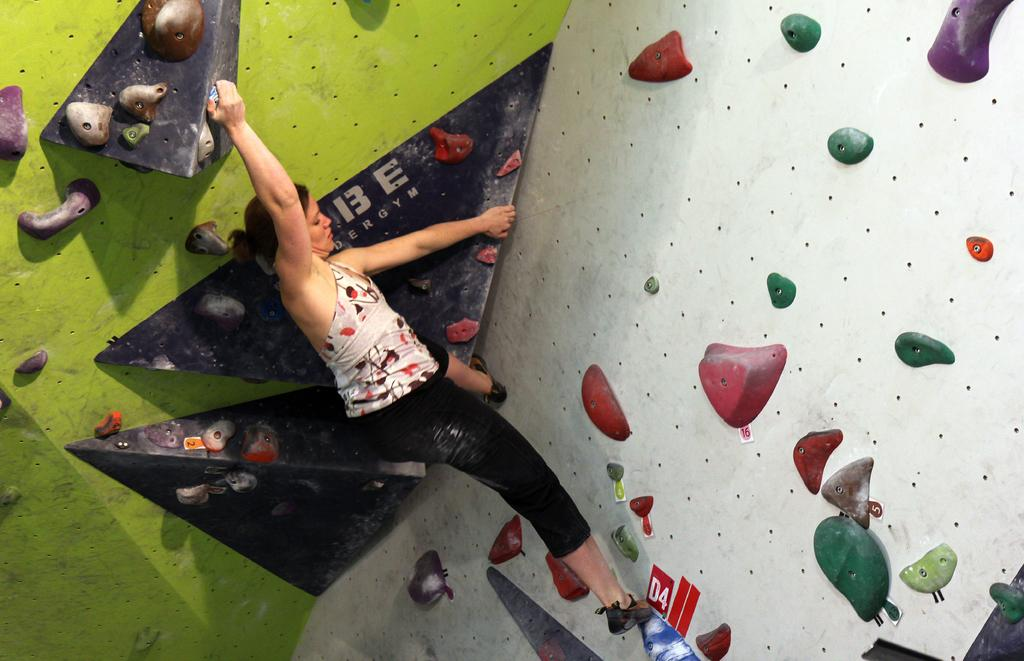Who is the main subject in the image? There is a woman in the image. What is the woman doing in the image? The woman is climbing a wall. What type of clothing is the woman wearing? The woman is wearing black pants. What type of vegetable is the woman holding in the image? There is no vegetable present in the image; the woman is climbing a wall. What statement is the woman making in the image? The image does not depict the woman making any statements; it only shows her climbing a wall. 